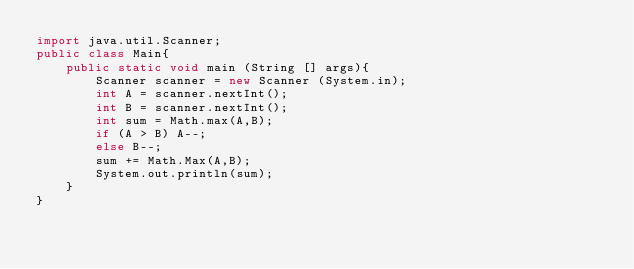<code> <loc_0><loc_0><loc_500><loc_500><_Java_>import java.util.Scanner;
public class Main{
  	public static void main (String [] args){
      	Scanner scanner = new Scanner (System.in);
      	int A = scanner.nextInt();
      	int B = scanner.nextInt();
      	int sum = Math.max(A,B);
      	if (A > B) A--;
        else B--;
      	sum += Math.Max(A,B);
      	System.out.println(sum);
    }
}</code> 